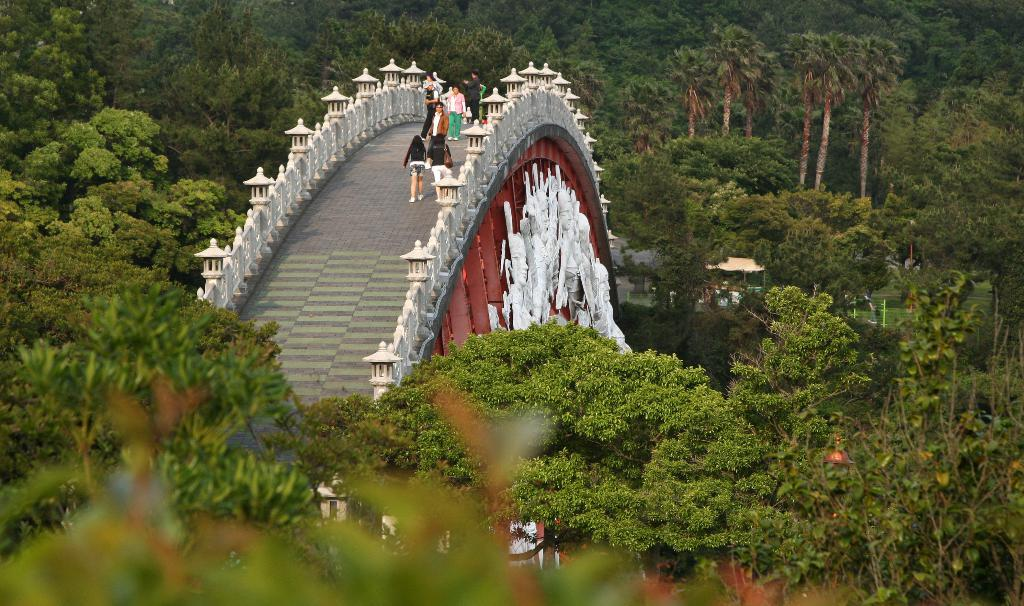What type of structure can be seen in the image? There is a bridge in the image. What decorative elements are present on the bridge? The bridge has sculptures. What are the people in the image doing? There are people walking on the bridge. What type of vegetation can be seen in the image? Trees are visible in the image. What type of ground cover is present in the image? Grass is present in the image. How many straws are being used by the people walking on the bridge in the image? There are no straws present in the image; people are walking on the bridge, not using straws. 